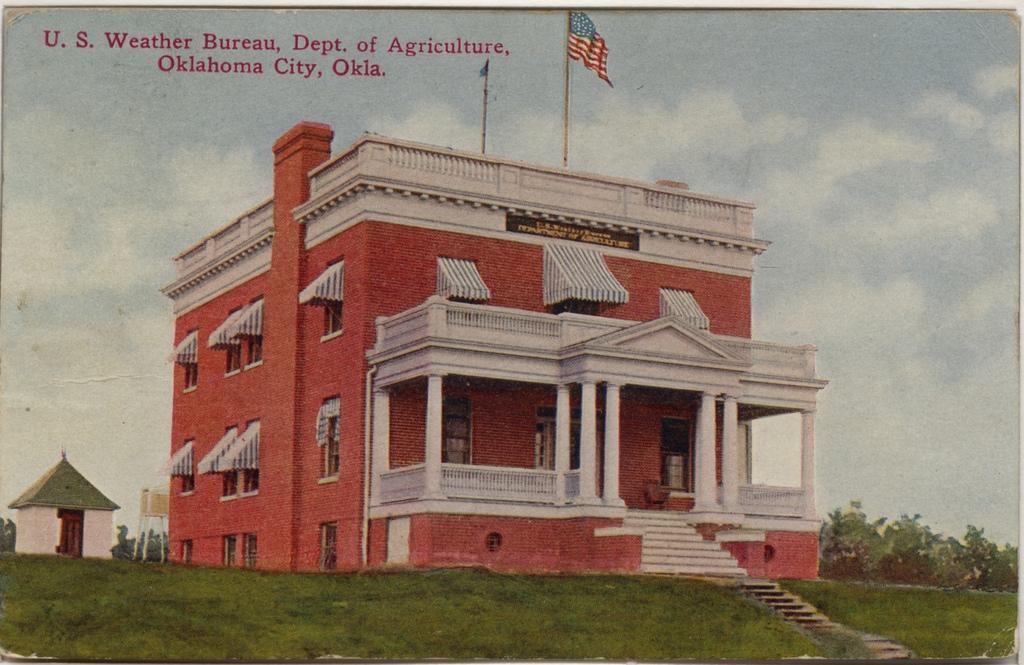Can you describe this image briefly? In this image at the center there is a building and in front of the building there are stairs. We can see flags on top of the building. At the bottom of the image there is grass on the surface. In the background there are trees and sky. 